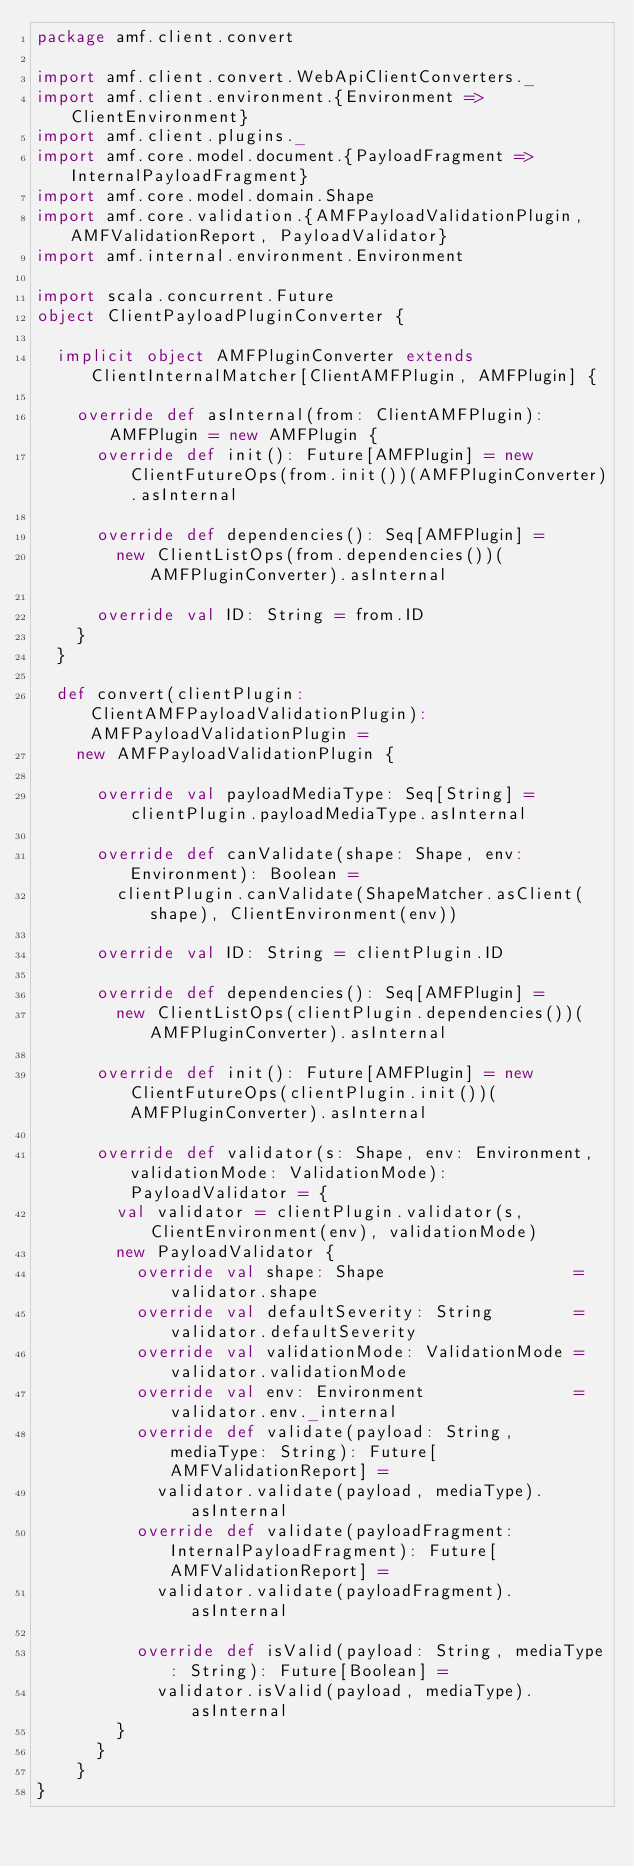<code> <loc_0><loc_0><loc_500><loc_500><_Scala_>package amf.client.convert

import amf.client.convert.WebApiClientConverters._
import amf.client.environment.{Environment => ClientEnvironment}
import amf.client.plugins._
import amf.core.model.document.{PayloadFragment => InternalPayloadFragment}
import amf.core.model.domain.Shape
import amf.core.validation.{AMFPayloadValidationPlugin, AMFValidationReport, PayloadValidator}
import amf.internal.environment.Environment

import scala.concurrent.Future
object ClientPayloadPluginConverter {

  implicit object AMFPluginConverter extends ClientInternalMatcher[ClientAMFPlugin, AMFPlugin] {

    override def asInternal(from: ClientAMFPlugin): AMFPlugin = new AMFPlugin {
      override def init(): Future[AMFPlugin] = new ClientFutureOps(from.init())(AMFPluginConverter).asInternal

      override def dependencies(): Seq[AMFPlugin] =
        new ClientListOps(from.dependencies())(AMFPluginConverter).asInternal

      override val ID: String = from.ID
    }
  }

  def convert(clientPlugin: ClientAMFPayloadValidationPlugin): AMFPayloadValidationPlugin =
    new AMFPayloadValidationPlugin {

      override val payloadMediaType: Seq[String] = clientPlugin.payloadMediaType.asInternal

      override def canValidate(shape: Shape, env: Environment): Boolean =
        clientPlugin.canValidate(ShapeMatcher.asClient(shape), ClientEnvironment(env))

      override val ID: String = clientPlugin.ID

      override def dependencies(): Seq[AMFPlugin] =
        new ClientListOps(clientPlugin.dependencies())(AMFPluginConverter).asInternal

      override def init(): Future[AMFPlugin] = new ClientFutureOps(clientPlugin.init())(AMFPluginConverter).asInternal

      override def validator(s: Shape, env: Environment, validationMode: ValidationMode): PayloadValidator = {
        val validator = clientPlugin.validator(s, ClientEnvironment(env), validationMode)
        new PayloadValidator {
          override val shape: Shape                   = validator.shape
          override val defaultSeverity: String        = validator.defaultSeverity
          override val validationMode: ValidationMode = validator.validationMode
          override val env: Environment               = validator.env._internal
          override def validate(payload: String, mediaType: String): Future[AMFValidationReport] =
            validator.validate(payload, mediaType).asInternal
          override def validate(payloadFragment: InternalPayloadFragment): Future[AMFValidationReport] =
            validator.validate(payloadFragment).asInternal

          override def isValid(payload: String, mediaType: String): Future[Boolean] =
            validator.isValid(payload, mediaType).asInternal
        }
      }
    }
}
</code> 